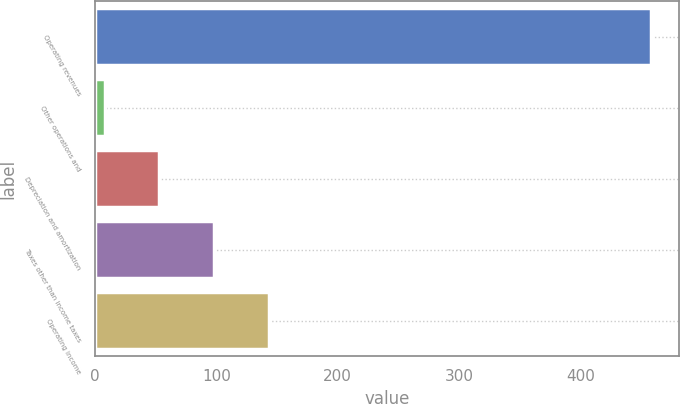Convert chart to OTSL. <chart><loc_0><loc_0><loc_500><loc_500><bar_chart><fcel>Operating revenues<fcel>Other operations and<fcel>Depreciation and amortization<fcel>Taxes other than income taxes<fcel>Operating income<nl><fcel>458<fcel>8<fcel>53<fcel>98<fcel>143<nl></chart> 